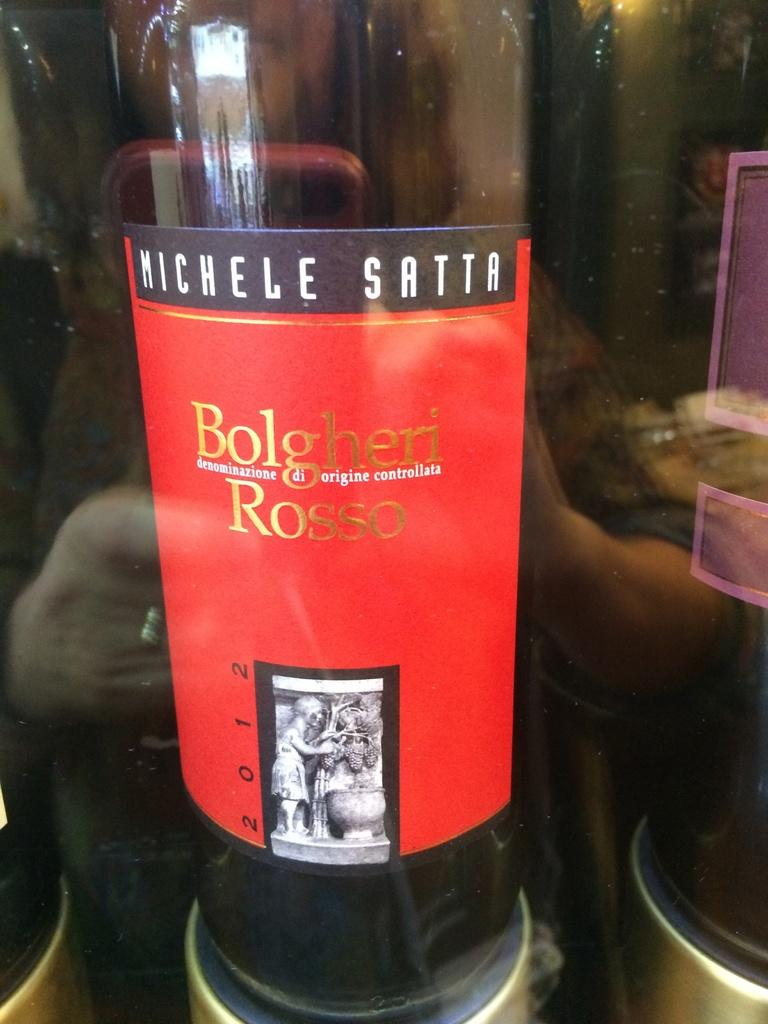<image>
Write a terse but informative summary of the picture. A bottle of Michele Satta is cooling inside of a refrigerator. 